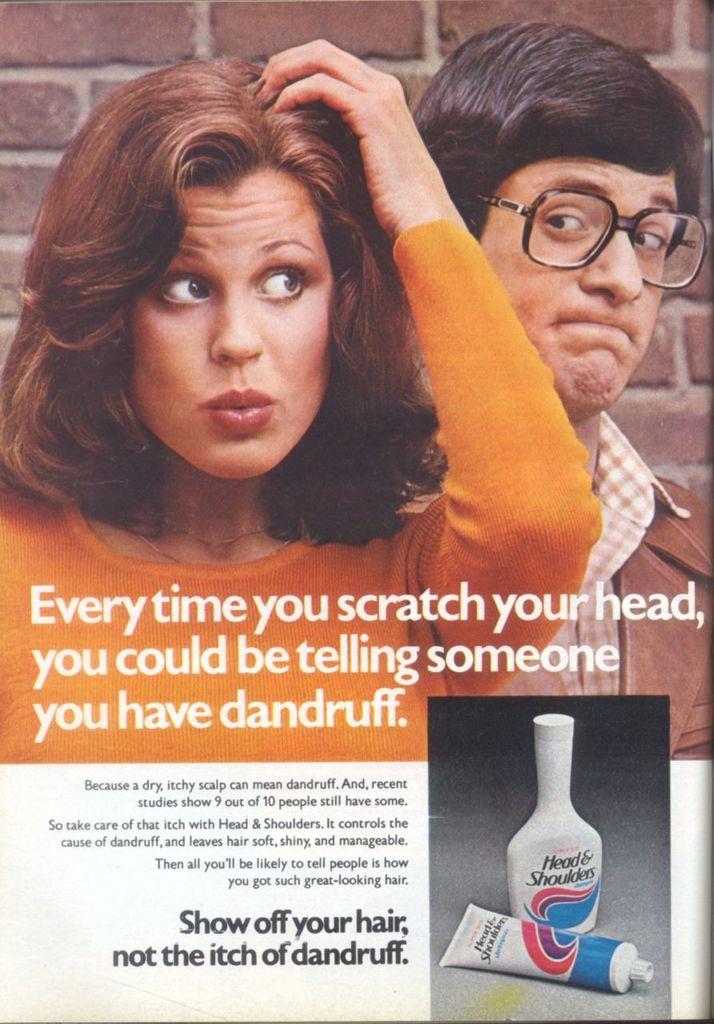What does the ad say could happen when you scratch your head?
Keep it short and to the point. You could be telling someone you have dandruff. 